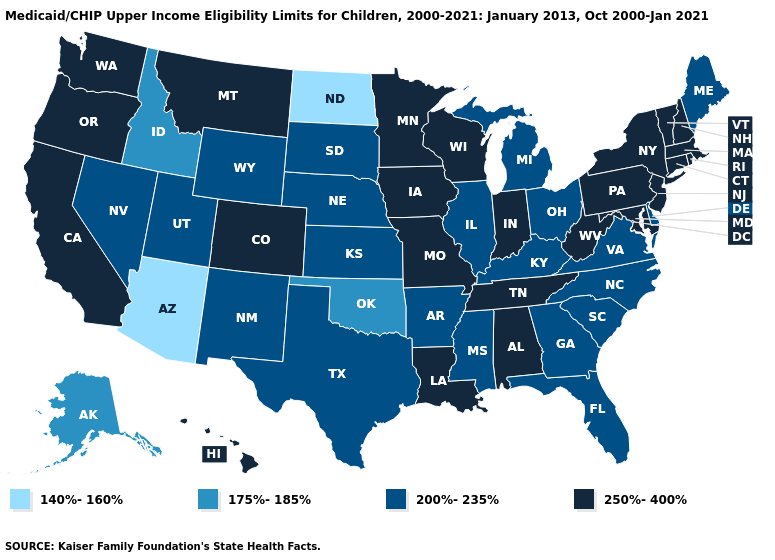Does Louisiana have the highest value in the South?
Short answer required. Yes. What is the value of Delaware?
Be succinct. 200%-235%. What is the value of Arizona?
Keep it brief. 140%-160%. What is the highest value in the USA?
Give a very brief answer. 250%-400%. What is the value of Georgia?
Keep it brief. 200%-235%. Which states have the lowest value in the Northeast?
Quick response, please. Maine. Name the states that have a value in the range 140%-160%?
Concise answer only. Arizona, North Dakota. Does the map have missing data?
Answer briefly. No. What is the value of Wisconsin?
Be succinct. 250%-400%. What is the value of Kansas?
Short answer required. 200%-235%. What is the highest value in the MidWest ?
Be succinct. 250%-400%. How many symbols are there in the legend?
Keep it brief. 4. Does South Carolina have the same value as Utah?
Concise answer only. Yes. What is the value of California?
Be succinct. 250%-400%. What is the highest value in the USA?
Concise answer only. 250%-400%. 